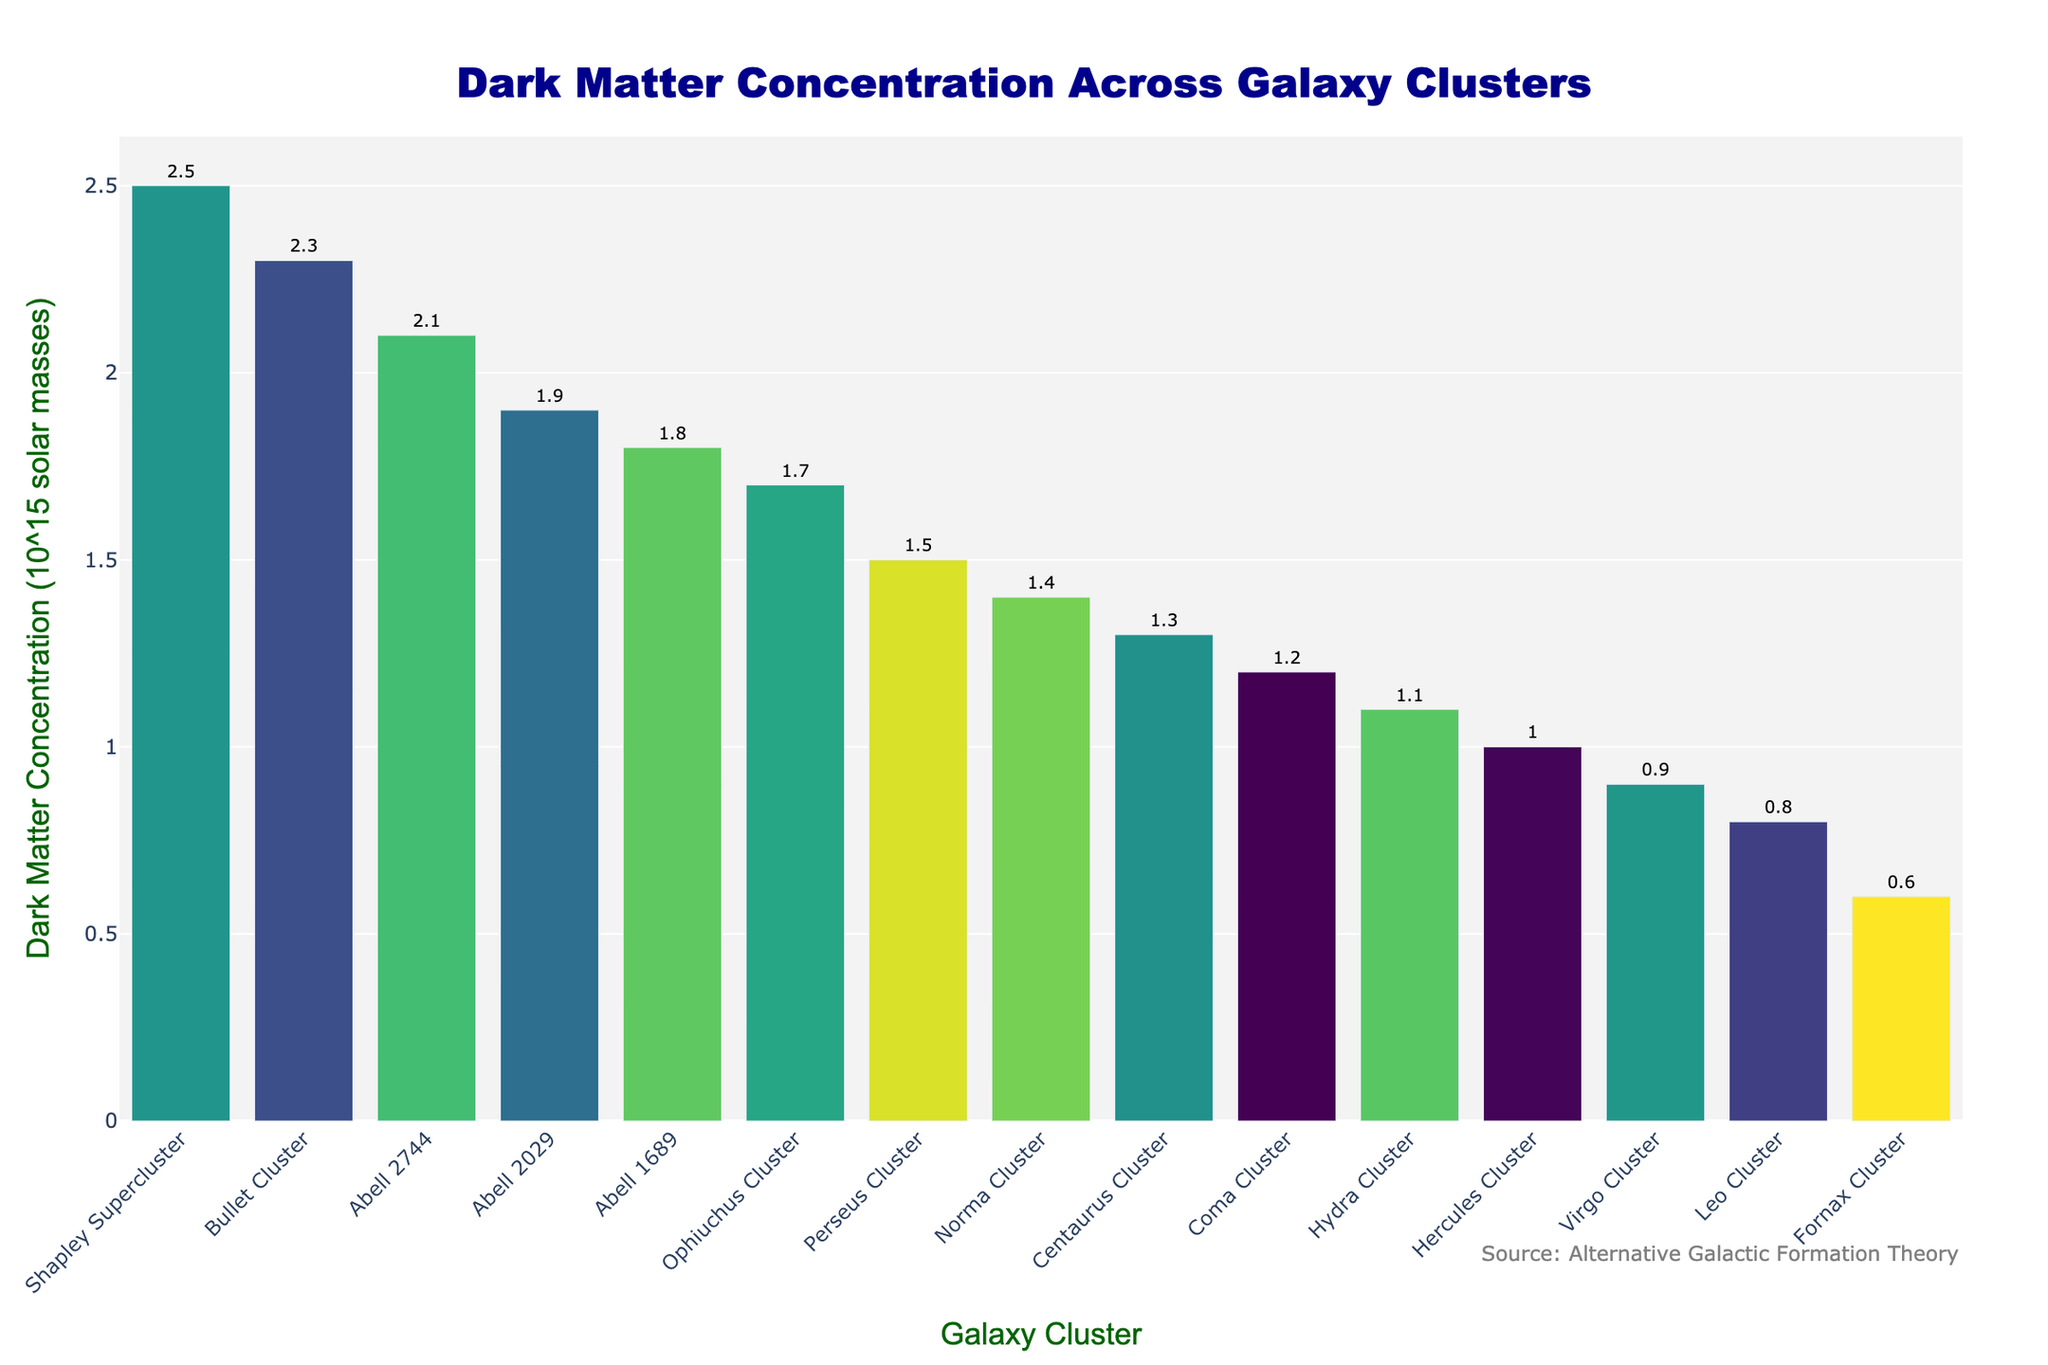Which galaxy cluster has the highest dark matter concentration? By examining the bar chart, the highest bar reaches the topmost position. The label below this bar indicates it represents the Shapley Supercluster.
Answer: Shapley Supercluster Which galaxy clusters have a dark matter concentration greater than 2.0 x 10^15 solar masses? By observing the height of the bars, identify those with labels showing values greater than 2.0. These bars represent Shapley Supercluster, Bullet Cluster, and Abell 2744.
Answer: Shapley Supercluster, Bullet Cluster, Abell 2744 What is the difference in dark matter concentration between the Bullet Cluster and the Coma Cluster? Locate the bars for Bullet Cluster and Coma Cluster. The Bullet Cluster has a concentration of 2.3, and the Coma Cluster has a concentration of 1.2. Subtract the values: 2.3 - 1.2.
Answer: 1.1 x 10^15 solar masses Which cluster has a higher dark matter concentration, Hydra Cluster or Leo Cluster? Find the bars for Hydra Cluster and Leo Cluster. The Hydra Cluster has a value of 1.1, and the Leo Cluster has a value of 0.8. The Hydra Cluster's value is higher.
Answer: Hydra Cluster What is the sum of dark matter concentrations for Abell 1689 and Virgo Cluster? Identify the bars for Abell 1689 and Virgo Cluster. Their concentrations are 1.8 and 0.9, respectively. Add the two values: 1.8 + 0.9.
Answer: 2.7 x 10^15 solar masses Are there more clusters with concentrations above 1.5 or below 1.0? Count the bars above 1.5 (Abell 1689, Ophiuchus Cluster, Abell 2029, Abell 2744, Bullet Cluster, and Shapley Supercluster - total 6) and below 1.0 (Virgo Cluster, Fornax Cluster, and Leo Cluster - total 3).
Answer: Above 1.5 Which cluster has the darkest shade of the colors used in the bar chart? The darkest shade corresponds to the highest value in the chosen colorscale. The Shapley Supercluster bar appears to have the darkest shade, aligning with the highest concentration.
Answer: Shapley Supercluster What is the average dark matter concentration of the clusters represented? Sum all the concentrations: 1.8 + 2.3 + 1.2 + 1.5 + 0.9 + 0.6 + 1.1 + 1.3 + 1.0 + 0.8 + 1.4 + 1.7 + 2.5 + 1.9 + 2.1 = 21.1. There are 15 clusters, so divide by 15: 21.1 / 15.
Answer: 1.41 x 10^15 solar masses 